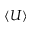Convert formula to latex. <formula><loc_0><loc_0><loc_500><loc_500>\langle U \rangle</formula> 